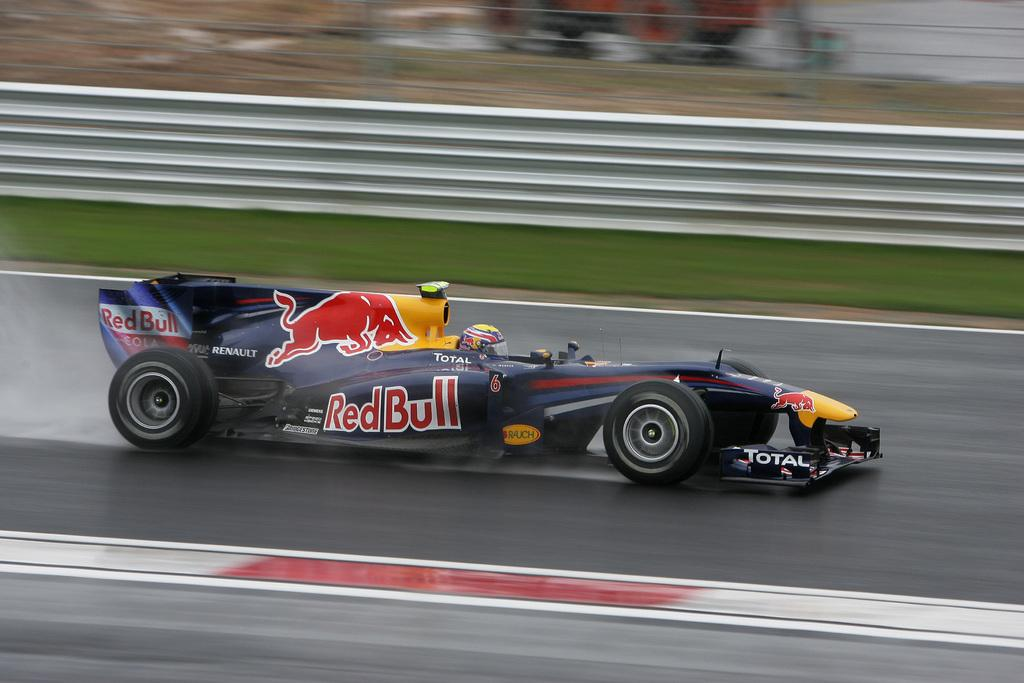What is the main subject of the image? The main subject of the image is a racing car. Where is the racing car located in the image? The racing car is on the road in the image. What can be seen inside the car? There is a helmet visible inside the car. What is visible in the background of the image? There is a wall in the background of the image. How is the wall depicted in the image? The wall appears blurry in the image. What type of lock is used to secure the news in the image? There is no lock or news present in the image; it features a racing car on the road with a helmet inside and a blurry wall in the background. 